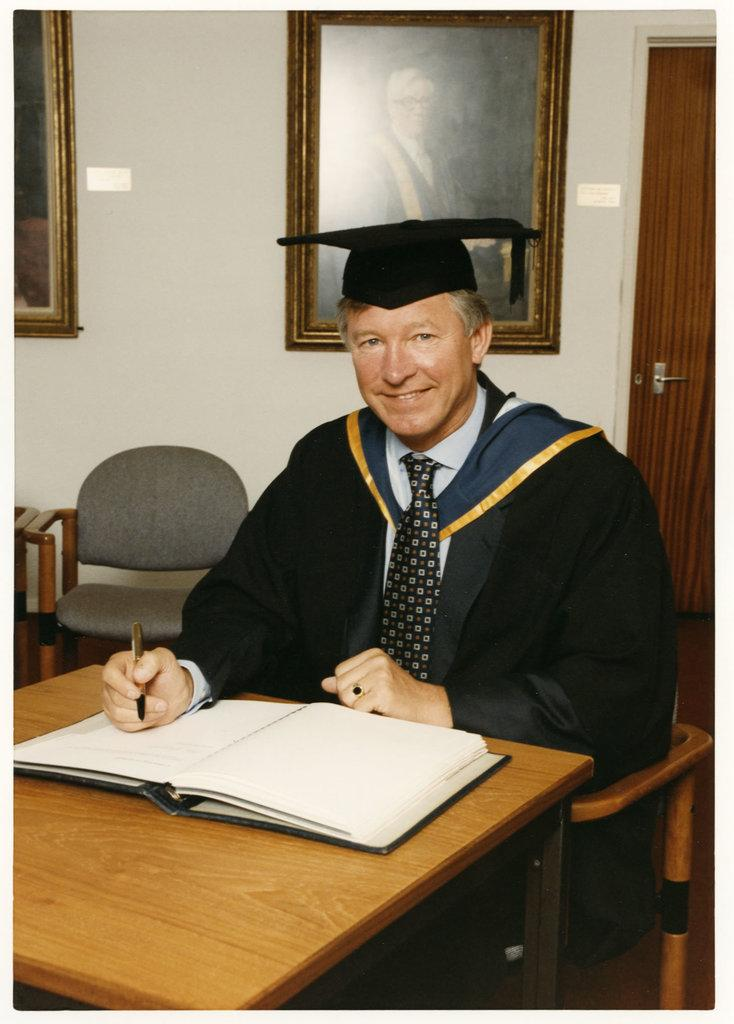Who is present in the image? There is a man in the image. What is the man doing in the image? The man is sitting at a table in the image. What is the man holding in the image? The man is holding a pen in the image. What is in front of the man on the table? There is a book in front of the man on the table. What type of cherry is the man eating in the image? There is no cherry present in the image; the man is holding a pen and there is a book in front of him. What musical instrument is the man playing in the image? There is no musical instrument present in the image; the man is holding a pen and there is a book in front of him. 